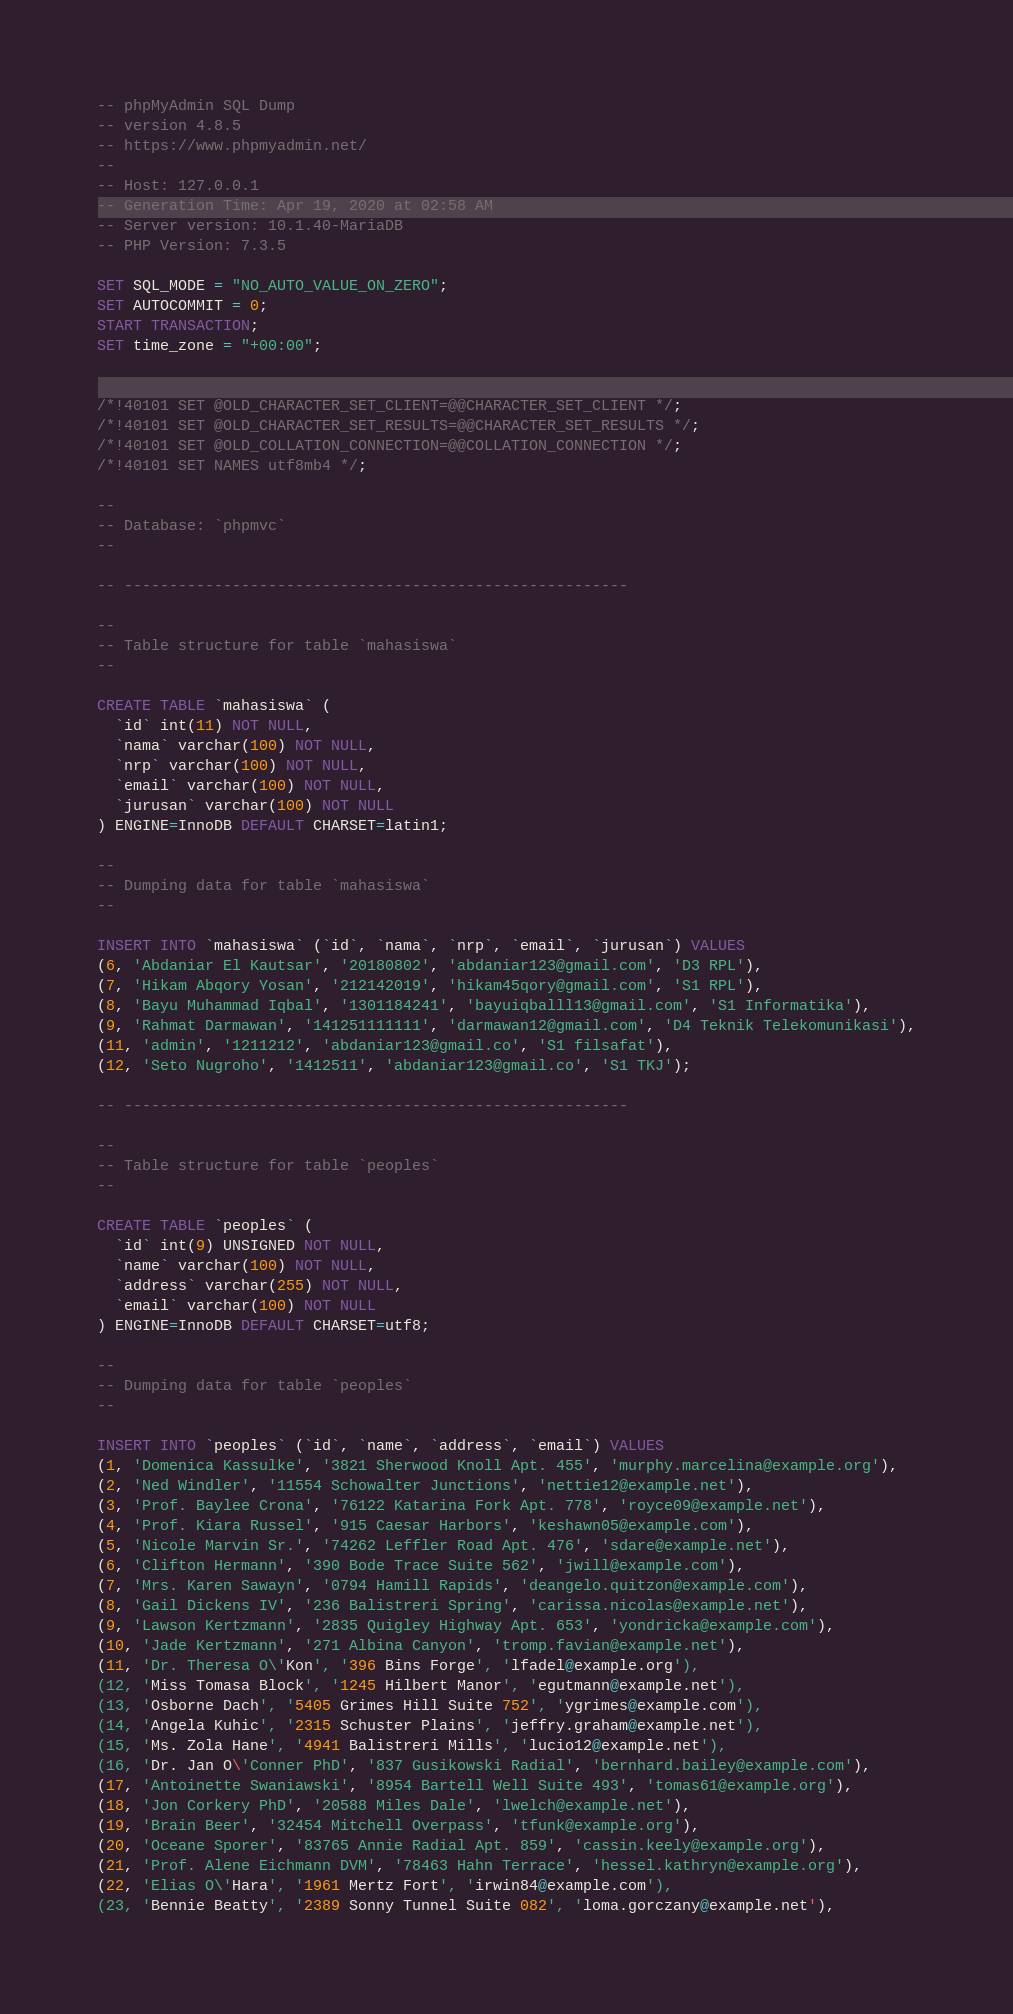Convert code to text. <code><loc_0><loc_0><loc_500><loc_500><_SQL_>-- phpMyAdmin SQL Dump
-- version 4.8.5
-- https://www.phpmyadmin.net/
--
-- Host: 127.0.0.1
-- Generation Time: Apr 19, 2020 at 02:58 AM
-- Server version: 10.1.40-MariaDB
-- PHP Version: 7.3.5

SET SQL_MODE = "NO_AUTO_VALUE_ON_ZERO";
SET AUTOCOMMIT = 0;
START TRANSACTION;
SET time_zone = "+00:00";


/*!40101 SET @OLD_CHARACTER_SET_CLIENT=@@CHARACTER_SET_CLIENT */;
/*!40101 SET @OLD_CHARACTER_SET_RESULTS=@@CHARACTER_SET_RESULTS */;
/*!40101 SET @OLD_COLLATION_CONNECTION=@@COLLATION_CONNECTION */;
/*!40101 SET NAMES utf8mb4 */;

--
-- Database: `phpmvc`
--

-- --------------------------------------------------------

--
-- Table structure for table `mahasiswa`
--

CREATE TABLE `mahasiswa` (
  `id` int(11) NOT NULL,
  `nama` varchar(100) NOT NULL,
  `nrp` varchar(100) NOT NULL,
  `email` varchar(100) NOT NULL,
  `jurusan` varchar(100) NOT NULL
) ENGINE=InnoDB DEFAULT CHARSET=latin1;

--
-- Dumping data for table `mahasiswa`
--

INSERT INTO `mahasiswa` (`id`, `nama`, `nrp`, `email`, `jurusan`) VALUES
(6, 'Abdaniar El Kautsar', '20180802', 'abdaniar123@gmail.com', 'D3 RPL'),
(7, 'Hikam Abqory Yosan', '212142019', 'hikam45qory@gmail.com', 'S1 RPL'),
(8, 'Bayu Muhammad Iqbal', '1301184241', 'bayuiqballl13@gmail.com', 'S1 Informatika'),
(9, 'Rahmat Darmawan', '141251111111', 'darmawan12@gmail.com', 'D4 Teknik Telekomunikasi'),
(11, 'admin', '1211212', 'abdaniar123@gmail.co', 'S1 filsafat'),
(12, 'Seto Nugroho', '1412511', 'abdaniar123@gmail.co', 'S1 TKJ');

-- --------------------------------------------------------

--
-- Table structure for table `peoples`
--

CREATE TABLE `peoples` (
  `id` int(9) UNSIGNED NOT NULL,
  `name` varchar(100) NOT NULL,
  `address` varchar(255) NOT NULL,
  `email` varchar(100) NOT NULL
) ENGINE=InnoDB DEFAULT CHARSET=utf8;

--
-- Dumping data for table `peoples`
--

INSERT INTO `peoples` (`id`, `name`, `address`, `email`) VALUES
(1, 'Domenica Kassulke', '3821 Sherwood Knoll Apt. 455', 'murphy.marcelina@example.org'),
(2, 'Ned Windler', '11554 Schowalter Junctions', 'nettie12@example.net'),
(3, 'Prof. Baylee Crona', '76122 Katarina Fork Apt. 778', 'royce09@example.net'),
(4, 'Prof. Kiara Russel', '915 Caesar Harbors', 'keshawn05@example.com'),
(5, 'Nicole Marvin Sr.', '74262 Leffler Road Apt. 476', 'sdare@example.net'),
(6, 'Clifton Hermann', '390 Bode Trace Suite 562', 'jwill@example.com'),
(7, 'Mrs. Karen Sawayn', '0794 Hamill Rapids', 'deangelo.quitzon@example.com'),
(8, 'Gail Dickens IV', '236 Balistreri Spring', 'carissa.nicolas@example.net'),
(9, 'Lawson Kertzmann', '2835 Quigley Highway Apt. 653', 'yondricka@example.com'),
(10, 'Jade Kertzmann', '271 Albina Canyon', 'tromp.favian@example.net'),
(11, 'Dr. Theresa O\'Kon', '396 Bins Forge', 'lfadel@example.org'),
(12, 'Miss Tomasa Block', '1245 Hilbert Manor', 'egutmann@example.net'),
(13, 'Osborne Dach', '5405 Grimes Hill Suite 752', 'ygrimes@example.com'),
(14, 'Angela Kuhic', '2315 Schuster Plains', 'jeffry.graham@example.net'),
(15, 'Ms. Zola Hane', '4941 Balistreri Mills', 'lucio12@example.net'),
(16, 'Dr. Jan O\'Conner PhD', '837 Gusikowski Radial', 'bernhard.bailey@example.com'),
(17, 'Antoinette Swaniawski', '8954 Bartell Well Suite 493', 'tomas61@example.org'),
(18, 'Jon Corkery PhD', '20588 Miles Dale', 'lwelch@example.net'),
(19, 'Brain Beer', '32454 Mitchell Overpass', 'tfunk@example.org'),
(20, 'Oceane Sporer', '83765 Annie Radial Apt. 859', 'cassin.keely@example.org'),
(21, 'Prof. Alene Eichmann DVM', '78463 Hahn Terrace', 'hessel.kathryn@example.org'),
(22, 'Elias O\'Hara', '1961 Mertz Fort', 'irwin84@example.com'),
(23, 'Bennie Beatty', '2389 Sonny Tunnel Suite 082', 'loma.gorczany@example.net'),</code> 